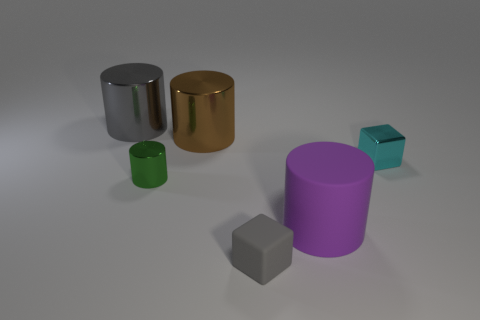There is a large cylinder that is the same color as the small rubber object; what is it made of?
Ensure brevity in your answer.  Metal. There is a gray matte thing; does it have the same size as the metal cylinder that is behind the large brown metal cylinder?
Ensure brevity in your answer.  No. There is a large gray shiny object; what shape is it?
Offer a terse response. Cylinder. There is a matte block; does it have the same color as the large thing on the left side of the brown object?
Your answer should be very brief. Yes. Are there an equal number of tiny cyan things on the left side of the green shiny thing and big blue rubber objects?
Your answer should be very brief. Yes. How many matte cubes are the same size as the cyan object?
Give a very brief answer. 1. What is the shape of the metal object that is the same color as the small matte thing?
Give a very brief answer. Cylinder. Are there any small yellow shiny things?
Make the answer very short. No. Do the large thing right of the small matte object and the small thing that is to the left of the tiny gray block have the same shape?
Ensure brevity in your answer.  Yes. How many small things are green matte cylinders or rubber cylinders?
Offer a terse response. 0. 